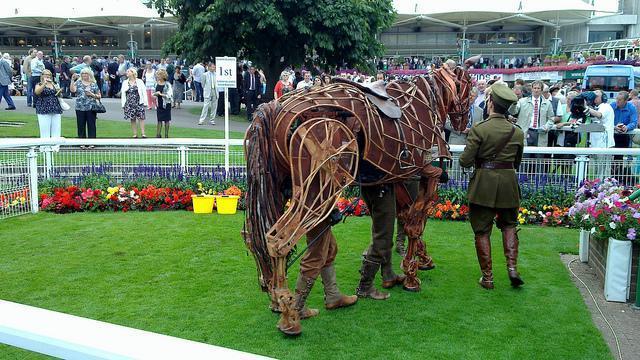How many potted plants are in the picture?
Give a very brief answer. 2. How many people are visible?
Give a very brief answer. 4. How many sandwiches with orange paste are in the picture?
Give a very brief answer. 0. 